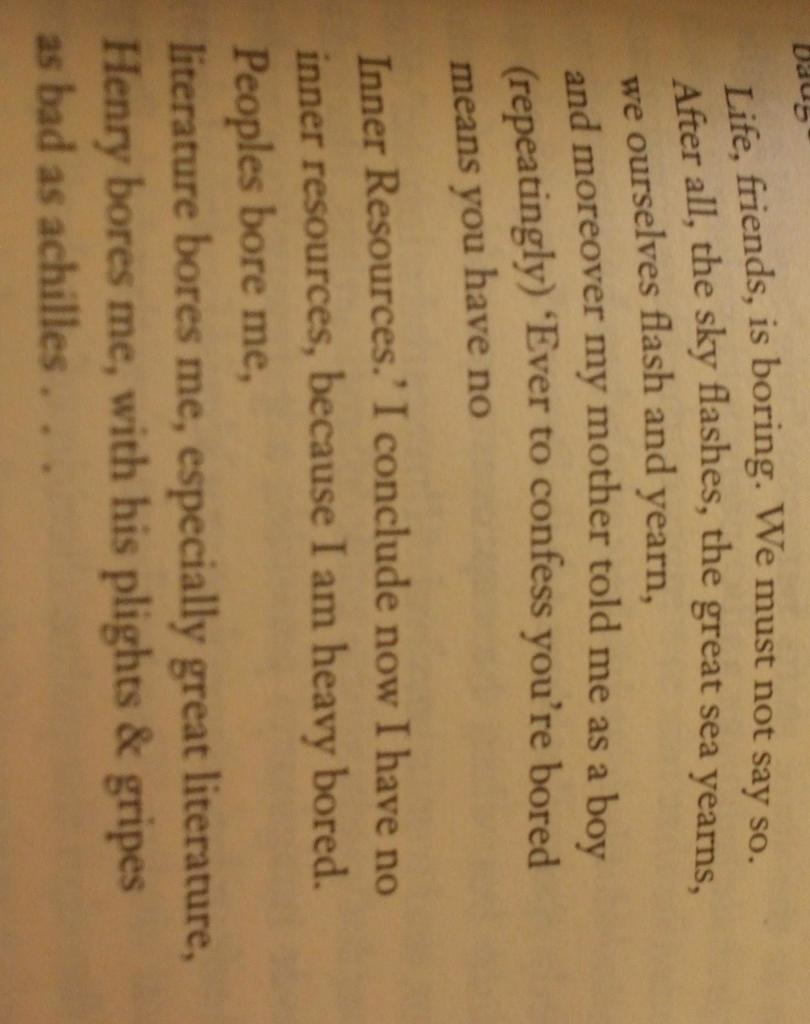<image>
Render a clear and concise summary of the photo. an excerpt of a book featuring characters like achilles and henry. 